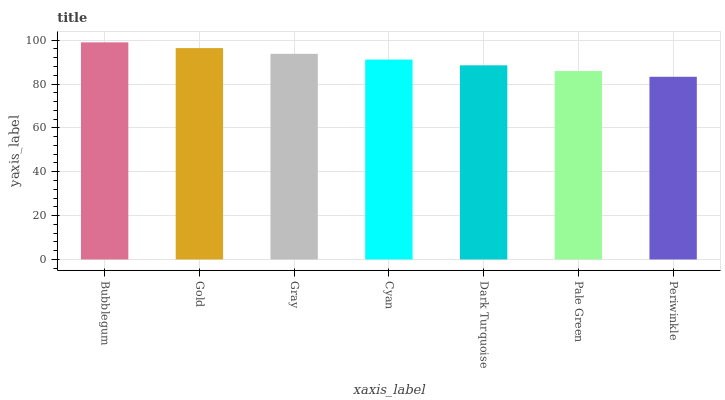Is Periwinkle the minimum?
Answer yes or no. Yes. Is Bubblegum the maximum?
Answer yes or no. Yes. Is Gold the minimum?
Answer yes or no. No. Is Gold the maximum?
Answer yes or no. No. Is Bubblegum greater than Gold?
Answer yes or no. Yes. Is Gold less than Bubblegum?
Answer yes or no. Yes. Is Gold greater than Bubblegum?
Answer yes or no. No. Is Bubblegum less than Gold?
Answer yes or no. No. Is Cyan the high median?
Answer yes or no. Yes. Is Cyan the low median?
Answer yes or no. Yes. Is Gray the high median?
Answer yes or no. No. Is Dark Turquoise the low median?
Answer yes or no. No. 